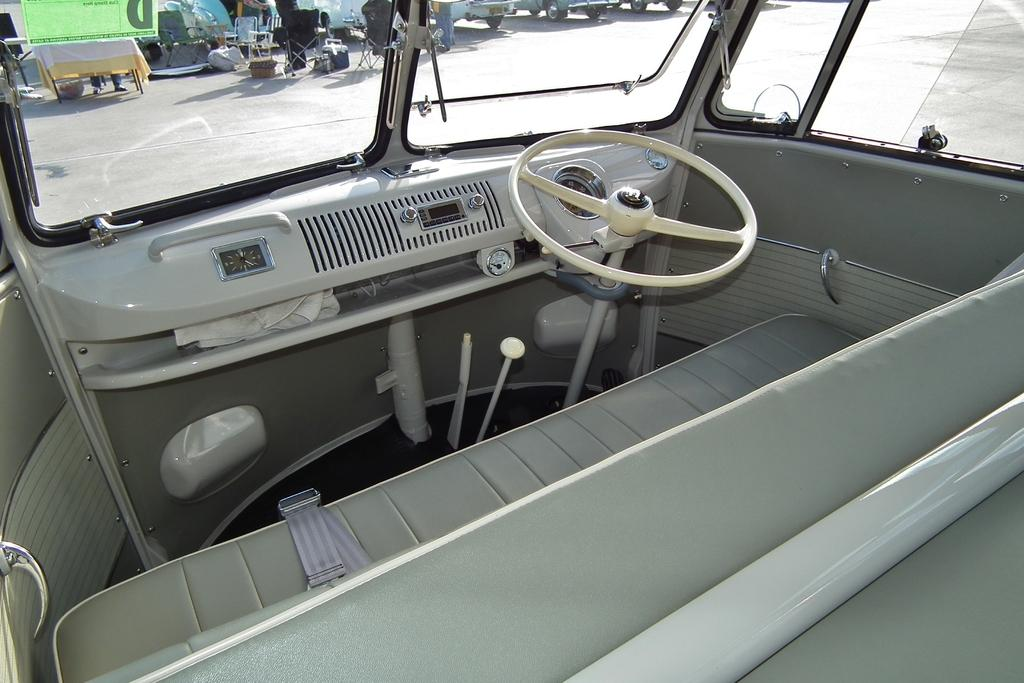What type of space is depicted in the image? The image shows the inside view of a vehicle. What is the main control device in the vehicle? There is a steering wheel in the image. What are the seating arrangements like in the vehicle? There are seats in the image. What allows passengers to see the outside environment? There are windows in the image. Can you see the daughter of the driver in the image? There is no information about a driver or their daughter in the image, so it cannot be determined if the daughter is present. Are there any snails crawling on the seats in the image? There are no snails visible in the image; it only shows the interior of a vehicle with seats, a steering wheel, and windows. 